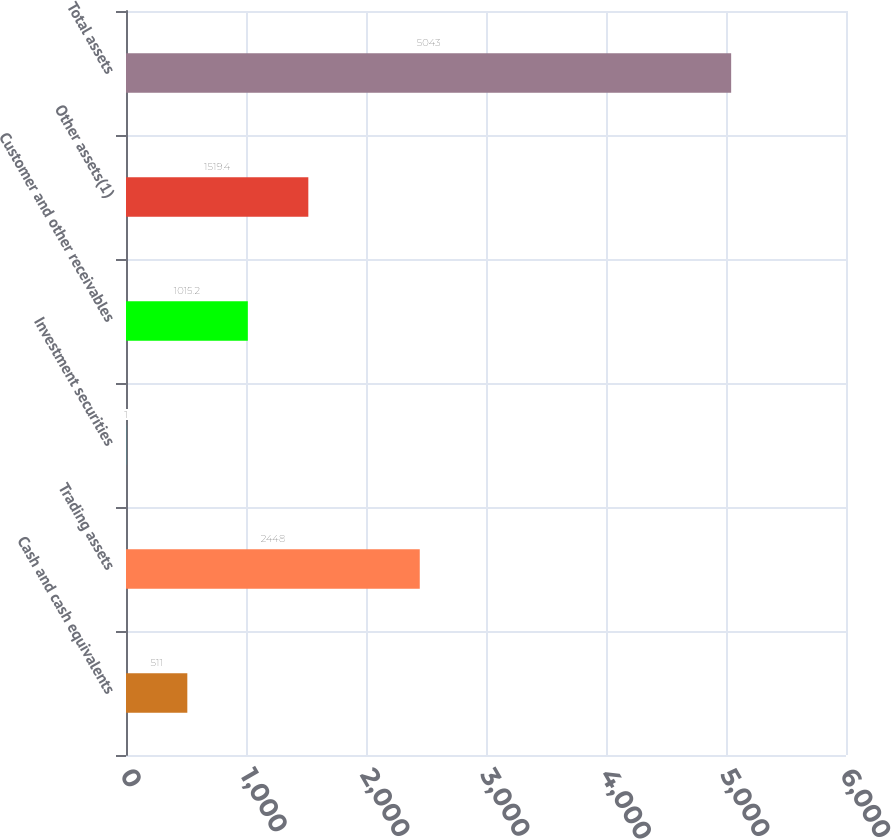Convert chart to OTSL. <chart><loc_0><loc_0><loc_500><loc_500><bar_chart><fcel>Cash and cash equivalents<fcel>Trading assets<fcel>Investment securities<fcel>Customer and other receivables<fcel>Other assets(1)<fcel>Total assets<nl><fcel>511<fcel>2448<fcel>1<fcel>1015.2<fcel>1519.4<fcel>5043<nl></chart> 